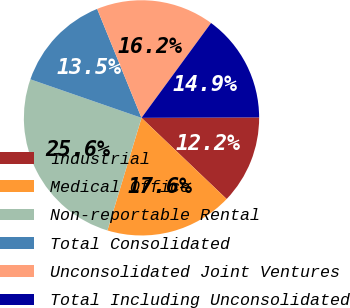<chart> <loc_0><loc_0><loc_500><loc_500><pie_chart><fcel>Industrial<fcel>Medical Office<fcel>Non-reportable Rental<fcel>Total Consolidated<fcel>Unconsolidated Joint Ventures<fcel>Total Including Unconsolidated<nl><fcel>12.18%<fcel>17.56%<fcel>25.63%<fcel>13.53%<fcel>16.22%<fcel>14.87%<nl></chart> 